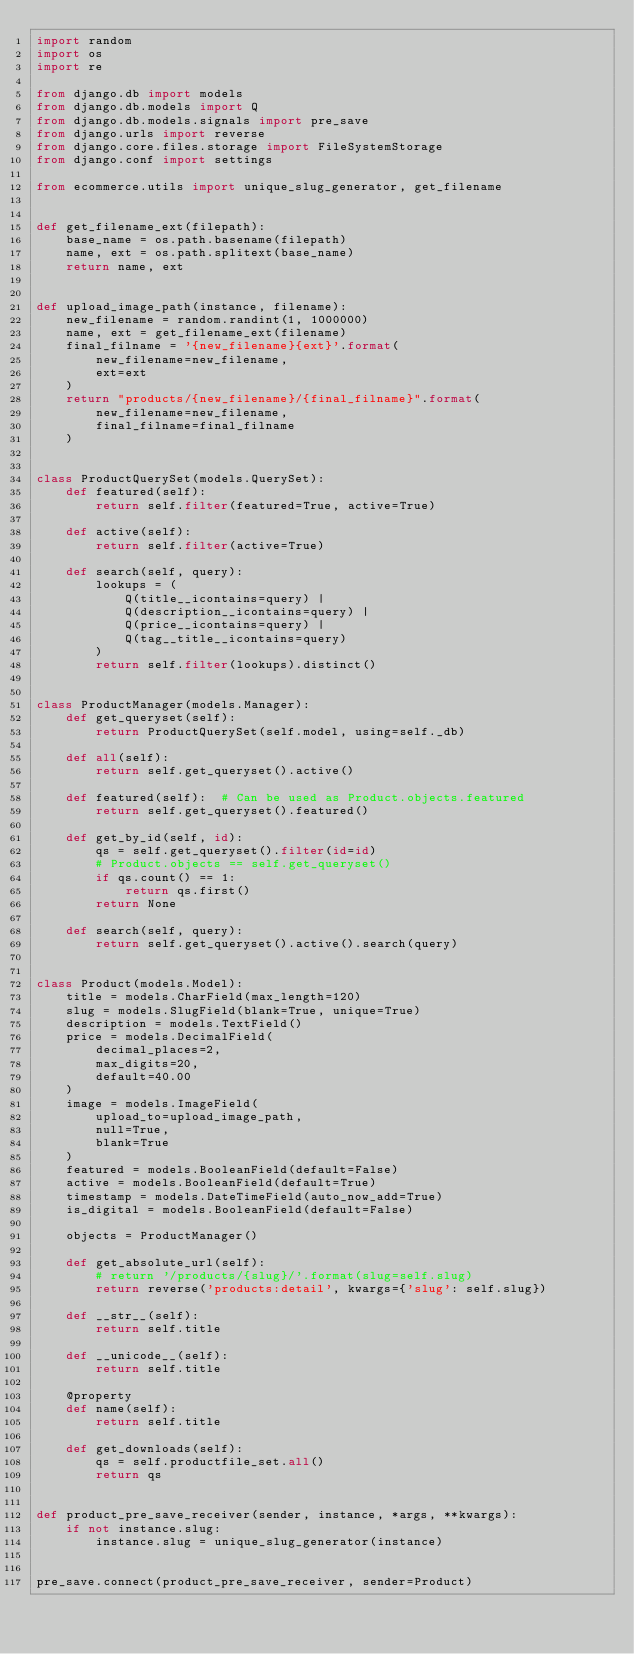Convert code to text. <code><loc_0><loc_0><loc_500><loc_500><_Python_>import random
import os
import re

from django.db import models
from django.db.models import Q
from django.db.models.signals import pre_save
from django.urls import reverse
from django.core.files.storage import FileSystemStorage
from django.conf import settings

from ecommerce.utils import unique_slug_generator, get_filename


def get_filename_ext(filepath):
    base_name = os.path.basename(filepath)
    name, ext = os.path.splitext(base_name)
    return name, ext


def upload_image_path(instance, filename):
    new_filename = random.randint(1, 1000000)
    name, ext = get_filename_ext(filename)
    final_filname = '{new_filename}{ext}'.format(
        new_filename=new_filename,
        ext=ext
    )
    return "products/{new_filename}/{final_filname}".format(
        new_filename=new_filename,
        final_filname=final_filname
    )


class ProductQuerySet(models.QuerySet):
    def featured(self):
        return self.filter(featured=True, active=True)

    def active(self):
        return self.filter(active=True)

    def search(self, query):
        lookups = (
            Q(title__icontains=query) |
            Q(description__icontains=query) |
            Q(price__icontains=query) |
            Q(tag__title__icontains=query)
        )
        return self.filter(lookups).distinct()


class ProductManager(models.Manager):
    def get_queryset(self):
        return ProductQuerySet(self.model, using=self._db)

    def all(self):
        return self.get_queryset().active()

    def featured(self):  # Can be used as Product.objects.featured
        return self.get_queryset().featured()

    def get_by_id(self, id):
        qs = self.get_queryset().filter(id=id)
        # Product.objects == self.get_queryset()
        if qs.count() == 1:
            return qs.first()
        return None

    def search(self, query):
        return self.get_queryset().active().search(query)


class Product(models.Model):
    title = models.CharField(max_length=120)
    slug = models.SlugField(blank=True, unique=True)
    description = models.TextField()
    price = models.DecimalField(
        decimal_places=2,
        max_digits=20,
        default=40.00
    )
    image = models.ImageField(
        upload_to=upload_image_path,
        null=True,
        blank=True
    )
    featured = models.BooleanField(default=False)
    active = models.BooleanField(default=True)
    timestamp = models.DateTimeField(auto_now_add=True)
    is_digital = models.BooleanField(default=False)

    objects = ProductManager()

    def get_absolute_url(self):
        # return '/products/{slug}/'.format(slug=self.slug)
        return reverse('products:detail', kwargs={'slug': self.slug})

    def __str__(self):
        return self.title

    def __unicode__(self):
        return self.title

    @property
    def name(self):
        return self.title

    def get_downloads(self):
        qs = self.productfile_set.all()
        return qs


def product_pre_save_receiver(sender, instance, *args, **kwargs):
    if not instance.slug:
        instance.slug = unique_slug_generator(instance)


pre_save.connect(product_pre_save_receiver, sender=Product)

</code> 